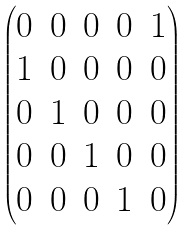Convert formula to latex. <formula><loc_0><loc_0><loc_500><loc_500>\begin{pmatrix} 0 & 0 & 0 & 0 & 1 \\ 1 & 0 & 0 & 0 & 0 \\ 0 & 1 & 0 & 0 & 0 \\ 0 & 0 & 1 & 0 & 0 \\ 0 & 0 & 0 & 1 & 0 \end{pmatrix}</formula> 